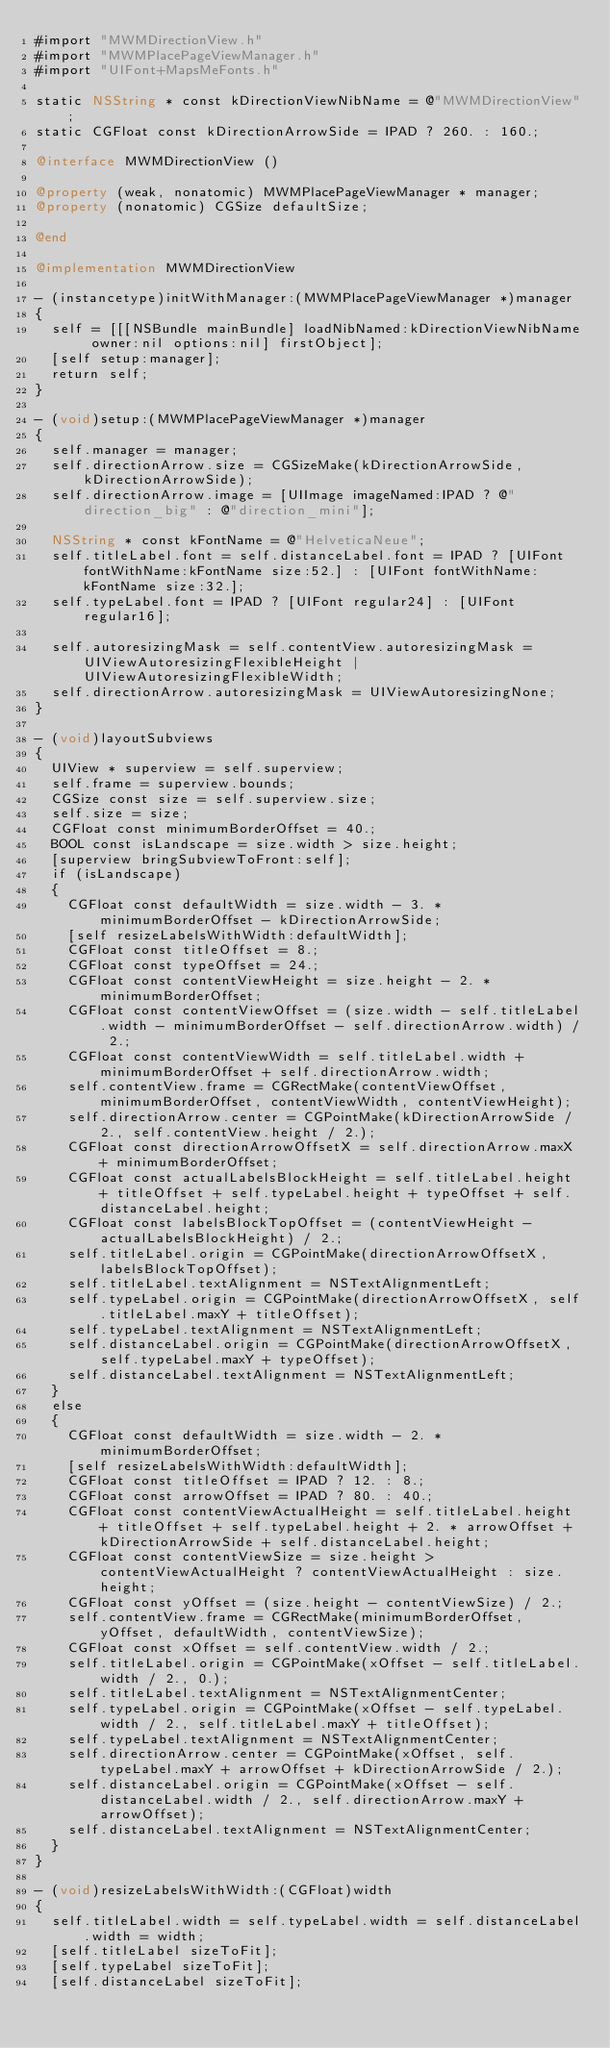<code> <loc_0><loc_0><loc_500><loc_500><_ObjectiveC_>#import "MWMDirectionView.h"
#import "MWMPlacePageViewManager.h"
#import "UIFont+MapsMeFonts.h"

static NSString * const kDirectionViewNibName = @"MWMDirectionView";
static CGFloat const kDirectionArrowSide = IPAD ? 260. : 160.;

@interface MWMDirectionView ()

@property (weak, nonatomic) MWMPlacePageViewManager * manager;
@property (nonatomic) CGSize defaultSize;

@end

@implementation MWMDirectionView

- (instancetype)initWithManager:(MWMPlacePageViewManager *)manager
{
  self = [[[NSBundle mainBundle] loadNibNamed:kDirectionViewNibName owner:nil options:nil] firstObject];
  [self setup:manager];
  return self;
}

- (void)setup:(MWMPlacePageViewManager *)manager
{
  self.manager = manager;
  self.directionArrow.size = CGSizeMake(kDirectionArrowSide, kDirectionArrowSide);
  self.directionArrow.image = [UIImage imageNamed:IPAD ? @"direction_big" : @"direction_mini"];

  NSString * const kFontName = @"HelveticaNeue";
  self.titleLabel.font = self.distanceLabel.font = IPAD ? [UIFont fontWithName:kFontName size:52.] : [UIFont fontWithName:kFontName size:32.];
  self.typeLabel.font = IPAD ? [UIFont regular24] : [UIFont regular16];

  self.autoresizingMask = self.contentView.autoresizingMask = UIViewAutoresizingFlexibleHeight | UIViewAutoresizingFlexibleWidth;
  self.directionArrow.autoresizingMask = UIViewAutoresizingNone;
}

- (void)layoutSubviews
{
  UIView * superview = self.superview;
  self.frame = superview.bounds;
  CGSize const size = self.superview.size;
  self.size = size;
  CGFloat const minimumBorderOffset = 40.;
  BOOL const isLandscape = size.width > size.height;
  [superview bringSubviewToFront:self];
  if (isLandscape)
  {
    CGFloat const defaultWidth = size.width - 3. * minimumBorderOffset - kDirectionArrowSide;
    [self resizeLabelsWithWidth:defaultWidth];
    CGFloat const titleOffset = 8.;
    CGFloat const typeOffset = 24.;
    CGFloat const contentViewHeight = size.height - 2. * minimumBorderOffset;
    CGFloat const contentViewOffset = (size.width - self.titleLabel.width - minimumBorderOffset - self.directionArrow.width) / 2.;
    CGFloat const contentViewWidth = self.titleLabel.width + minimumBorderOffset + self.directionArrow.width;
    self.contentView.frame = CGRectMake(contentViewOffset, minimumBorderOffset, contentViewWidth, contentViewHeight);
    self.directionArrow.center = CGPointMake(kDirectionArrowSide / 2., self.contentView.height / 2.);
    CGFloat const directionArrowOffsetX = self.directionArrow.maxX + minimumBorderOffset;
    CGFloat const actualLabelsBlockHeight = self.titleLabel.height + titleOffset + self.typeLabel.height + typeOffset + self.distanceLabel.height;
    CGFloat const labelsBlockTopOffset = (contentViewHeight - actualLabelsBlockHeight) / 2.;
    self.titleLabel.origin = CGPointMake(directionArrowOffsetX, labelsBlockTopOffset);
    self.titleLabel.textAlignment = NSTextAlignmentLeft;
    self.typeLabel.origin = CGPointMake(directionArrowOffsetX, self.titleLabel.maxY + titleOffset);
    self.typeLabel.textAlignment = NSTextAlignmentLeft;
    self.distanceLabel.origin = CGPointMake(directionArrowOffsetX, self.typeLabel.maxY + typeOffset);
    self.distanceLabel.textAlignment = NSTextAlignmentLeft;
  }
  else
  {
    CGFloat const defaultWidth = size.width - 2. * minimumBorderOffset;
    [self resizeLabelsWithWidth:defaultWidth];
    CGFloat const titleOffset = IPAD ? 12. : 8.;
    CGFloat const arrowOffset = IPAD ? 80. : 40.;
    CGFloat const contentViewActualHeight = self.titleLabel.height + titleOffset + self.typeLabel.height + 2. * arrowOffset + kDirectionArrowSide + self.distanceLabel.height;
    CGFloat const contentViewSize = size.height > contentViewActualHeight ? contentViewActualHeight : size.height;
    CGFloat const yOffset = (size.height - contentViewSize) / 2.;
    self.contentView.frame = CGRectMake(minimumBorderOffset, yOffset, defaultWidth, contentViewSize);
    CGFloat const xOffset = self.contentView.width / 2.;
    self.titleLabel.origin = CGPointMake(xOffset - self.titleLabel.width / 2., 0.);
    self.titleLabel.textAlignment = NSTextAlignmentCenter;
    self.typeLabel.origin = CGPointMake(xOffset - self.typeLabel.width / 2., self.titleLabel.maxY + titleOffset);
    self.typeLabel.textAlignment = NSTextAlignmentCenter;
    self.directionArrow.center = CGPointMake(xOffset, self.typeLabel.maxY + arrowOffset + kDirectionArrowSide / 2.);
    self.distanceLabel.origin = CGPointMake(xOffset - self.distanceLabel.width / 2., self.directionArrow.maxY + arrowOffset);
    self.distanceLabel.textAlignment = NSTextAlignmentCenter;
  }
}

- (void)resizeLabelsWithWidth:(CGFloat)width
{
  self.titleLabel.width = self.typeLabel.width = self.distanceLabel.width = width;
  [self.titleLabel sizeToFit];
  [self.typeLabel sizeToFit];
  [self.distanceLabel sizeToFit];</code> 